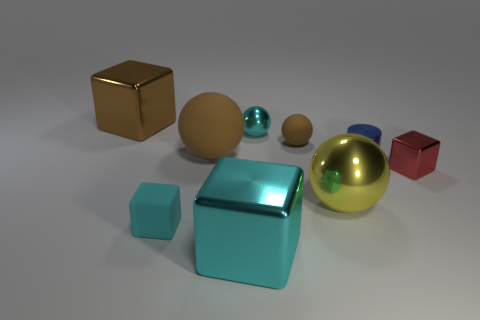Add 1 tiny blue shiny things. How many objects exist? 10 Subtract all balls. How many objects are left? 5 Add 9 small blue cubes. How many small blue cubes exist? 9 Subtract 0 gray blocks. How many objects are left? 9 Subtract all big brown matte balls. Subtract all tiny metallic objects. How many objects are left? 5 Add 4 tiny cyan matte things. How many tiny cyan matte things are left? 5 